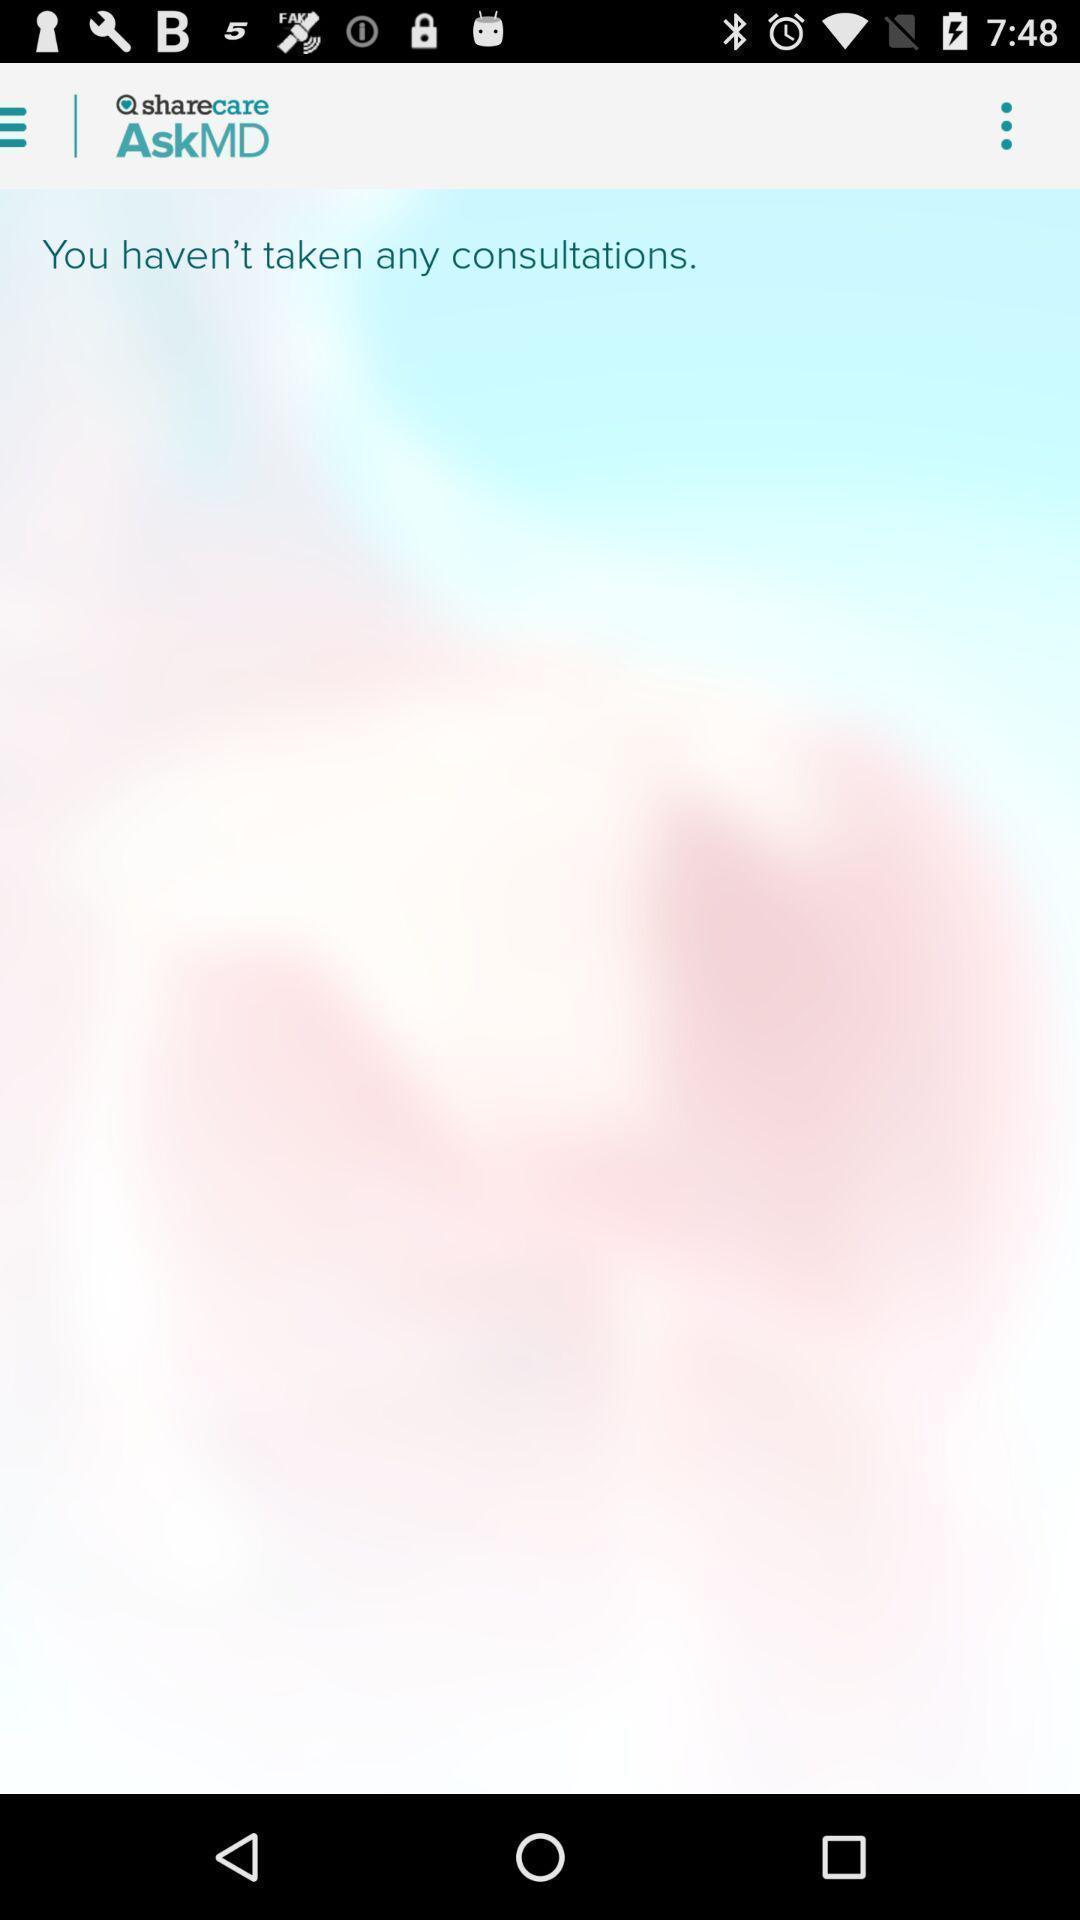Describe this image in words. Window displaying an medical app. 